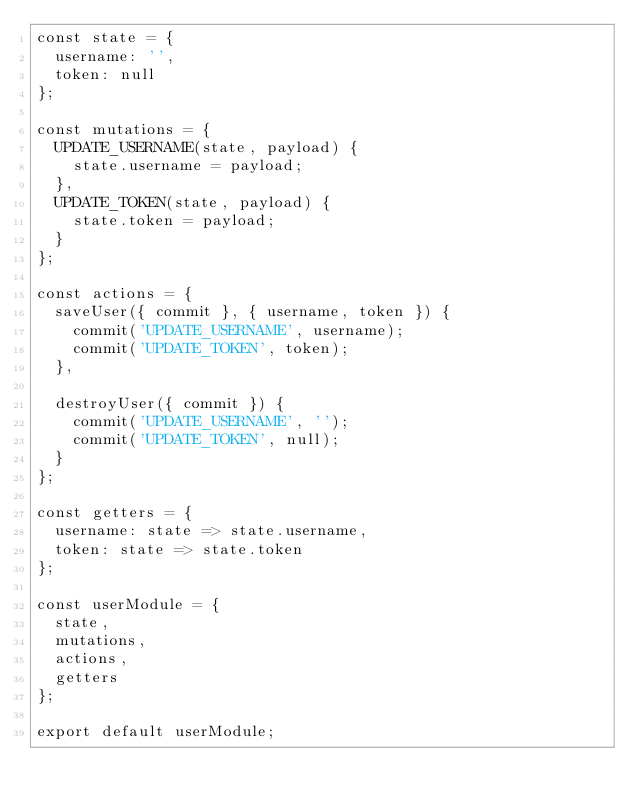<code> <loc_0><loc_0><loc_500><loc_500><_JavaScript_>const state = {
  username: '',
  token: null
};

const mutations = {
  UPDATE_USERNAME(state, payload) {
    state.username = payload;
  },
  UPDATE_TOKEN(state, payload) {
    state.token = payload;
  }
};

const actions = {
  saveUser({ commit }, { username, token }) {
    commit('UPDATE_USERNAME', username);
    commit('UPDATE_TOKEN', token);
  },

  destroyUser({ commit }) {
    commit('UPDATE_USERNAME', '');
    commit('UPDATE_TOKEN', null);
  }
};

const getters = {
  username: state => state.username,
  token: state => state.token
};

const userModule = {
  state,
  mutations,
  actions,
  getters
};

export default userModule;</code> 